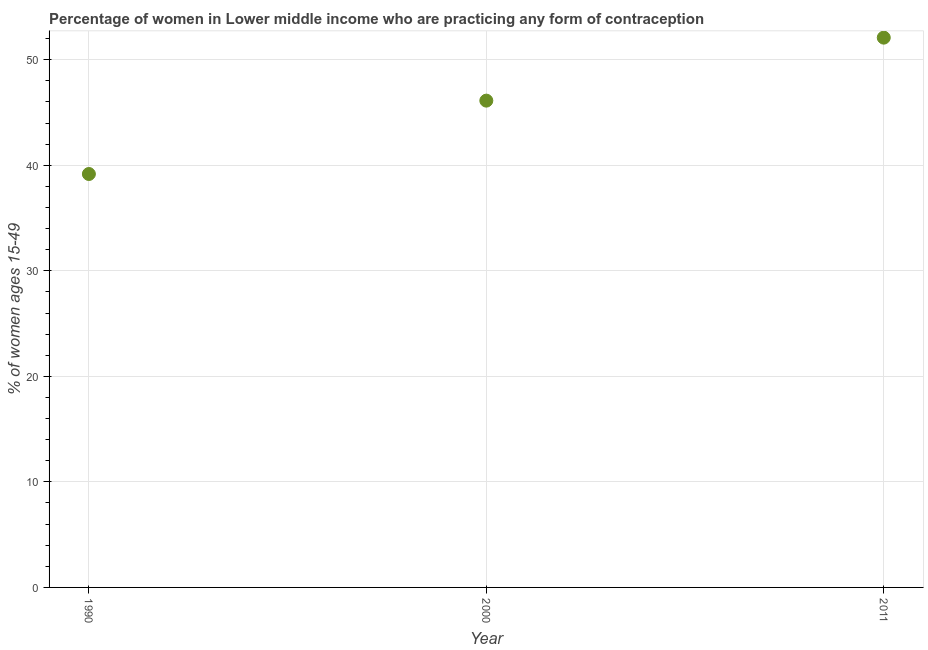What is the contraceptive prevalence in 2000?
Your answer should be very brief. 46.13. Across all years, what is the maximum contraceptive prevalence?
Offer a very short reply. 52.09. Across all years, what is the minimum contraceptive prevalence?
Make the answer very short. 39.17. In which year was the contraceptive prevalence maximum?
Offer a very short reply. 2011. In which year was the contraceptive prevalence minimum?
Offer a very short reply. 1990. What is the sum of the contraceptive prevalence?
Ensure brevity in your answer.  137.4. What is the difference between the contraceptive prevalence in 1990 and 2011?
Provide a succinct answer. -12.92. What is the average contraceptive prevalence per year?
Provide a short and direct response. 45.8. What is the median contraceptive prevalence?
Make the answer very short. 46.13. In how many years, is the contraceptive prevalence greater than 20 %?
Your answer should be very brief. 3. Do a majority of the years between 2000 and 2011 (inclusive) have contraceptive prevalence greater than 42 %?
Provide a succinct answer. Yes. What is the ratio of the contraceptive prevalence in 1990 to that in 2011?
Keep it short and to the point. 0.75. Is the contraceptive prevalence in 2000 less than that in 2011?
Provide a succinct answer. Yes. Is the difference between the contraceptive prevalence in 1990 and 2000 greater than the difference between any two years?
Your answer should be compact. No. What is the difference between the highest and the second highest contraceptive prevalence?
Ensure brevity in your answer.  5.97. Is the sum of the contraceptive prevalence in 1990 and 2000 greater than the maximum contraceptive prevalence across all years?
Your response must be concise. Yes. What is the difference between the highest and the lowest contraceptive prevalence?
Give a very brief answer. 12.92. Does the contraceptive prevalence monotonically increase over the years?
Make the answer very short. Yes. How many dotlines are there?
Offer a terse response. 1. What is the difference between two consecutive major ticks on the Y-axis?
Offer a very short reply. 10. What is the title of the graph?
Your answer should be compact. Percentage of women in Lower middle income who are practicing any form of contraception. What is the label or title of the Y-axis?
Offer a very short reply. % of women ages 15-49. What is the % of women ages 15-49 in 1990?
Make the answer very short. 39.17. What is the % of women ages 15-49 in 2000?
Provide a succinct answer. 46.13. What is the % of women ages 15-49 in 2011?
Provide a succinct answer. 52.09. What is the difference between the % of women ages 15-49 in 1990 and 2000?
Your answer should be compact. -6.95. What is the difference between the % of women ages 15-49 in 1990 and 2011?
Make the answer very short. -12.92. What is the difference between the % of women ages 15-49 in 2000 and 2011?
Provide a succinct answer. -5.97. What is the ratio of the % of women ages 15-49 in 1990 to that in 2000?
Offer a terse response. 0.85. What is the ratio of the % of women ages 15-49 in 1990 to that in 2011?
Your answer should be very brief. 0.75. What is the ratio of the % of women ages 15-49 in 2000 to that in 2011?
Your answer should be very brief. 0.89. 